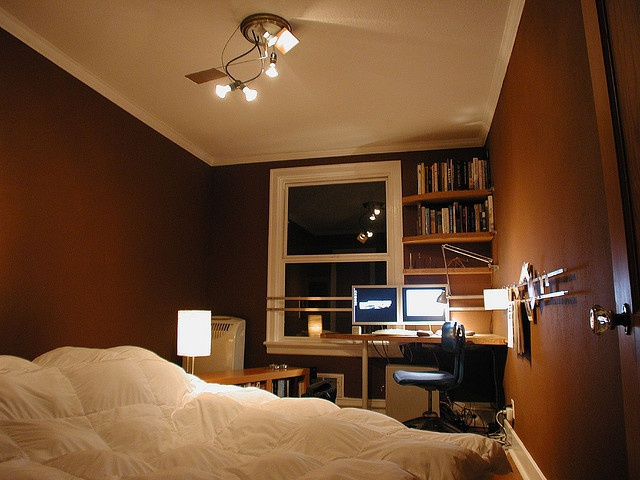Describe the objects in this image and their specific colors. I can see bed in maroon, gray, tan, and olive tones, book in maroon, black, and brown tones, chair in maroon, black, darkgray, and lightgray tones, tv in maroon, white, darkgray, and gray tones, and tv in maroon, navy, white, black, and gray tones in this image. 